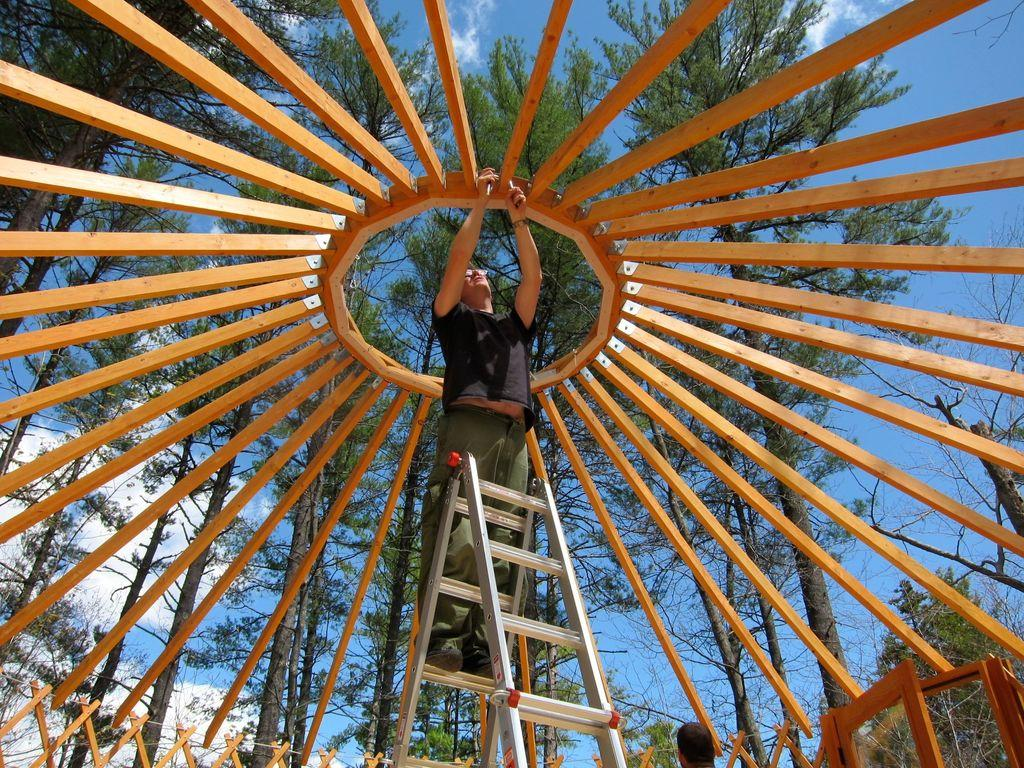Who or what is in the image? There is a person in the image. What is the person doing in the image? The person is on a ladder. What is the ladder positioned under? The ladder is under a wooden canopy. What can be seen in the background of the image? There are trees and the sky visible in the background of the image. What news is the person reading while on the ladder? There is no indication in the image that the person is reading any news. 